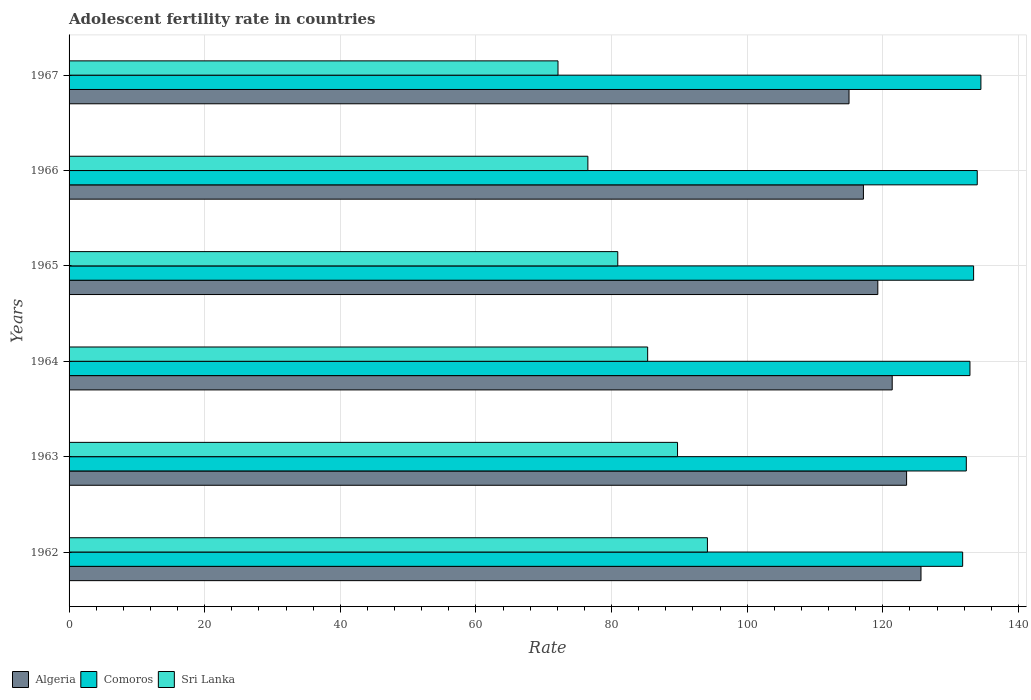Are the number of bars per tick equal to the number of legend labels?
Provide a succinct answer. Yes. What is the label of the 1st group of bars from the top?
Offer a terse response. 1967. In how many cases, is the number of bars for a given year not equal to the number of legend labels?
Offer a terse response. 0. What is the adolescent fertility rate in Comoros in 1963?
Your response must be concise. 132.31. Across all years, what is the maximum adolescent fertility rate in Algeria?
Your response must be concise. 125.62. Across all years, what is the minimum adolescent fertility rate in Sri Lanka?
Make the answer very short. 72.1. In which year was the adolescent fertility rate in Sri Lanka maximum?
Offer a terse response. 1962. In which year was the adolescent fertility rate in Sri Lanka minimum?
Your answer should be compact. 1967. What is the total adolescent fertility rate in Comoros in the graph?
Offer a very short reply. 798.68. What is the difference between the adolescent fertility rate in Algeria in 1962 and that in 1966?
Provide a short and direct response. 8.49. What is the difference between the adolescent fertility rate in Comoros in 1966 and the adolescent fertility rate in Sri Lanka in 1965?
Provide a succinct answer. 53.01. What is the average adolescent fertility rate in Algeria per year?
Your response must be concise. 120.32. In the year 1966, what is the difference between the adolescent fertility rate in Sri Lanka and adolescent fertility rate in Comoros?
Your response must be concise. -57.42. In how many years, is the adolescent fertility rate in Algeria greater than 92 ?
Provide a succinct answer. 6. What is the ratio of the adolescent fertility rate in Sri Lanka in 1966 to that in 1967?
Offer a terse response. 1.06. Is the difference between the adolescent fertility rate in Sri Lanka in 1963 and 1965 greater than the difference between the adolescent fertility rate in Comoros in 1963 and 1965?
Your answer should be very brief. Yes. What is the difference between the highest and the second highest adolescent fertility rate in Sri Lanka?
Provide a succinct answer. 4.41. What is the difference between the highest and the lowest adolescent fertility rate in Algeria?
Offer a terse response. 10.61. In how many years, is the adolescent fertility rate in Comoros greater than the average adolescent fertility rate in Comoros taken over all years?
Offer a very short reply. 3. What does the 3rd bar from the top in 1967 represents?
Offer a very short reply. Algeria. What does the 3rd bar from the bottom in 1965 represents?
Ensure brevity in your answer.  Sri Lanka. What is the difference between two consecutive major ticks on the X-axis?
Provide a short and direct response. 20. Does the graph contain any zero values?
Keep it short and to the point. No. Does the graph contain grids?
Give a very brief answer. Yes. Where does the legend appear in the graph?
Offer a terse response. Bottom left. How are the legend labels stacked?
Make the answer very short. Horizontal. What is the title of the graph?
Keep it short and to the point. Adolescent fertility rate in countries. Does "Equatorial Guinea" appear as one of the legend labels in the graph?
Provide a short and direct response. No. What is the label or title of the X-axis?
Your answer should be compact. Rate. What is the label or title of the Y-axis?
Your answer should be very brief. Years. What is the Rate in Algeria in 1962?
Provide a succinct answer. 125.62. What is the Rate in Comoros in 1962?
Your answer should be compact. 131.77. What is the Rate in Sri Lanka in 1962?
Your response must be concise. 94.13. What is the Rate in Algeria in 1963?
Ensure brevity in your answer.  123.5. What is the Rate of Comoros in 1963?
Your answer should be very brief. 132.31. What is the Rate in Sri Lanka in 1963?
Offer a very short reply. 89.72. What is the Rate in Algeria in 1964?
Provide a succinct answer. 121.38. What is the Rate in Comoros in 1964?
Make the answer very short. 132.84. What is the Rate in Sri Lanka in 1964?
Ensure brevity in your answer.  85.32. What is the Rate in Algeria in 1965?
Give a very brief answer. 119.26. What is the Rate in Comoros in 1965?
Provide a succinct answer. 133.38. What is the Rate of Sri Lanka in 1965?
Your answer should be very brief. 80.91. What is the Rate in Algeria in 1966?
Keep it short and to the point. 117.13. What is the Rate of Comoros in 1966?
Keep it short and to the point. 133.92. What is the Rate of Sri Lanka in 1966?
Offer a terse response. 76.5. What is the Rate in Algeria in 1967?
Offer a terse response. 115.01. What is the Rate in Comoros in 1967?
Make the answer very short. 134.46. What is the Rate in Sri Lanka in 1967?
Your response must be concise. 72.1. Across all years, what is the maximum Rate in Algeria?
Provide a succinct answer. 125.62. Across all years, what is the maximum Rate of Comoros?
Ensure brevity in your answer.  134.46. Across all years, what is the maximum Rate of Sri Lanka?
Provide a short and direct response. 94.13. Across all years, what is the minimum Rate of Algeria?
Keep it short and to the point. 115.01. Across all years, what is the minimum Rate of Comoros?
Your answer should be very brief. 131.77. Across all years, what is the minimum Rate of Sri Lanka?
Your answer should be very brief. 72.1. What is the total Rate in Algeria in the graph?
Offer a terse response. 721.91. What is the total Rate in Comoros in the graph?
Your answer should be compact. 798.68. What is the total Rate in Sri Lanka in the graph?
Keep it short and to the point. 498.68. What is the difference between the Rate of Algeria in 1962 and that in 1963?
Your answer should be very brief. 2.12. What is the difference between the Rate in Comoros in 1962 and that in 1963?
Your response must be concise. -0.54. What is the difference between the Rate in Sri Lanka in 1962 and that in 1963?
Offer a terse response. 4.41. What is the difference between the Rate of Algeria in 1962 and that in 1964?
Ensure brevity in your answer.  4.24. What is the difference between the Rate in Comoros in 1962 and that in 1964?
Give a very brief answer. -1.08. What is the difference between the Rate of Sri Lanka in 1962 and that in 1964?
Make the answer very short. 8.81. What is the difference between the Rate of Algeria in 1962 and that in 1965?
Your answer should be compact. 6.37. What is the difference between the Rate in Comoros in 1962 and that in 1965?
Offer a terse response. -1.61. What is the difference between the Rate of Sri Lanka in 1962 and that in 1965?
Provide a succinct answer. 13.22. What is the difference between the Rate in Algeria in 1962 and that in 1966?
Your response must be concise. 8.49. What is the difference between the Rate in Comoros in 1962 and that in 1966?
Offer a terse response. -2.15. What is the difference between the Rate in Sri Lanka in 1962 and that in 1966?
Your response must be concise. 17.63. What is the difference between the Rate in Algeria in 1962 and that in 1967?
Your response must be concise. 10.61. What is the difference between the Rate of Comoros in 1962 and that in 1967?
Provide a short and direct response. -2.69. What is the difference between the Rate of Sri Lanka in 1962 and that in 1967?
Keep it short and to the point. 22.03. What is the difference between the Rate of Algeria in 1963 and that in 1964?
Provide a short and direct response. 2.12. What is the difference between the Rate in Comoros in 1963 and that in 1964?
Offer a terse response. -0.54. What is the difference between the Rate of Sri Lanka in 1963 and that in 1964?
Your answer should be compact. 4.41. What is the difference between the Rate of Algeria in 1963 and that in 1965?
Your response must be concise. 4.24. What is the difference between the Rate in Comoros in 1963 and that in 1965?
Offer a very short reply. -1.08. What is the difference between the Rate of Sri Lanka in 1963 and that in 1965?
Your answer should be compact. 8.81. What is the difference between the Rate of Algeria in 1963 and that in 1966?
Your answer should be compact. 6.37. What is the difference between the Rate in Comoros in 1963 and that in 1966?
Your response must be concise. -1.61. What is the difference between the Rate of Sri Lanka in 1963 and that in 1966?
Provide a succinct answer. 13.22. What is the difference between the Rate of Algeria in 1963 and that in 1967?
Offer a very short reply. 8.49. What is the difference between the Rate of Comoros in 1963 and that in 1967?
Give a very brief answer. -2.15. What is the difference between the Rate in Sri Lanka in 1963 and that in 1967?
Your answer should be very brief. 17.63. What is the difference between the Rate in Algeria in 1964 and that in 1965?
Your response must be concise. 2.12. What is the difference between the Rate in Comoros in 1964 and that in 1965?
Provide a short and direct response. -0.54. What is the difference between the Rate of Sri Lanka in 1964 and that in 1965?
Give a very brief answer. 4.41. What is the difference between the Rate in Algeria in 1964 and that in 1966?
Provide a short and direct response. 4.24. What is the difference between the Rate of Comoros in 1964 and that in 1966?
Offer a terse response. -1.08. What is the difference between the Rate in Sri Lanka in 1964 and that in 1966?
Keep it short and to the point. 8.81. What is the difference between the Rate of Algeria in 1964 and that in 1967?
Your answer should be very brief. 6.37. What is the difference between the Rate in Comoros in 1964 and that in 1967?
Provide a short and direct response. -1.61. What is the difference between the Rate of Sri Lanka in 1964 and that in 1967?
Your answer should be compact. 13.22. What is the difference between the Rate in Algeria in 1965 and that in 1966?
Offer a terse response. 2.12. What is the difference between the Rate of Comoros in 1965 and that in 1966?
Provide a succinct answer. -0.54. What is the difference between the Rate in Sri Lanka in 1965 and that in 1966?
Give a very brief answer. 4.41. What is the difference between the Rate of Algeria in 1965 and that in 1967?
Your answer should be compact. 4.24. What is the difference between the Rate of Comoros in 1965 and that in 1967?
Your answer should be very brief. -1.08. What is the difference between the Rate in Sri Lanka in 1965 and that in 1967?
Provide a succinct answer. 8.81. What is the difference between the Rate in Algeria in 1966 and that in 1967?
Provide a short and direct response. 2.12. What is the difference between the Rate of Comoros in 1966 and that in 1967?
Your response must be concise. -0.54. What is the difference between the Rate in Sri Lanka in 1966 and that in 1967?
Ensure brevity in your answer.  4.41. What is the difference between the Rate of Algeria in 1962 and the Rate of Comoros in 1963?
Provide a succinct answer. -6.68. What is the difference between the Rate of Algeria in 1962 and the Rate of Sri Lanka in 1963?
Provide a short and direct response. 35.9. What is the difference between the Rate in Comoros in 1962 and the Rate in Sri Lanka in 1963?
Make the answer very short. 42.04. What is the difference between the Rate of Algeria in 1962 and the Rate of Comoros in 1964?
Your answer should be very brief. -7.22. What is the difference between the Rate in Algeria in 1962 and the Rate in Sri Lanka in 1964?
Offer a very short reply. 40.31. What is the difference between the Rate in Comoros in 1962 and the Rate in Sri Lanka in 1964?
Offer a very short reply. 46.45. What is the difference between the Rate in Algeria in 1962 and the Rate in Comoros in 1965?
Offer a very short reply. -7.76. What is the difference between the Rate of Algeria in 1962 and the Rate of Sri Lanka in 1965?
Keep it short and to the point. 44.71. What is the difference between the Rate in Comoros in 1962 and the Rate in Sri Lanka in 1965?
Provide a succinct answer. 50.86. What is the difference between the Rate in Algeria in 1962 and the Rate in Comoros in 1966?
Your answer should be compact. -8.3. What is the difference between the Rate of Algeria in 1962 and the Rate of Sri Lanka in 1966?
Your answer should be compact. 49.12. What is the difference between the Rate in Comoros in 1962 and the Rate in Sri Lanka in 1966?
Ensure brevity in your answer.  55.26. What is the difference between the Rate of Algeria in 1962 and the Rate of Comoros in 1967?
Provide a short and direct response. -8.83. What is the difference between the Rate of Algeria in 1962 and the Rate of Sri Lanka in 1967?
Your answer should be very brief. 53.53. What is the difference between the Rate of Comoros in 1962 and the Rate of Sri Lanka in 1967?
Offer a terse response. 59.67. What is the difference between the Rate of Algeria in 1963 and the Rate of Comoros in 1964?
Offer a terse response. -9.34. What is the difference between the Rate in Algeria in 1963 and the Rate in Sri Lanka in 1964?
Your response must be concise. 38.18. What is the difference between the Rate of Comoros in 1963 and the Rate of Sri Lanka in 1964?
Offer a very short reply. 46.99. What is the difference between the Rate in Algeria in 1963 and the Rate in Comoros in 1965?
Provide a succinct answer. -9.88. What is the difference between the Rate of Algeria in 1963 and the Rate of Sri Lanka in 1965?
Give a very brief answer. 42.59. What is the difference between the Rate in Comoros in 1963 and the Rate in Sri Lanka in 1965?
Keep it short and to the point. 51.4. What is the difference between the Rate of Algeria in 1963 and the Rate of Comoros in 1966?
Offer a very short reply. -10.42. What is the difference between the Rate in Algeria in 1963 and the Rate in Sri Lanka in 1966?
Your response must be concise. 47. What is the difference between the Rate in Comoros in 1963 and the Rate in Sri Lanka in 1966?
Offer a very short reply. 55.8. What is the difference between the Rate in Algeria in 1963 and the Rate in Comoros in 1967?
Ensure brevity in your answer.  -10.96. What is the difference between the Rate in Algeria in 1963 and the Rate in Sri Lanka in 1967?
Your response must be concise. 51.4. What is the difference between the Rate in Comoros in 1963 and the Rate in Sri Lanka in 1967?
Your answer should be very brief. 60.21. What is the difference between the Rate in Algeria in 1964 and the Rate in Comoros in 1965?
Provide a short and direct response. -12. What is the difference between the Rate in Algeria in 1964 and the Rate in Sri Lanka in 1965?
Your answer should be very brief. 40.47. What is the difference between the Rate of Comoros in 1964 and the Rate of Sri Lanka in 1965?
Provide a short and direct response. 51.93. What is the difference between the Rate of Algeria in 1964 and the Rate of Comoros in 1966?
Your response must be concise. -12.54. What is the difference between the Rate in Algeria in 1964 and the Rate in Sri Lanka in 1966?
Your response must be concise. 44.88. What is the difference between the Rate of Comoros in 1964 and the Rate of Sri Lanka in 1966?
Make the answer very short. 56.34. What is the difference between the Rate in Algeria in 1964 and the Rate in Comoros in 1967?
Provide a short and direct response. -13.08. What is the difference between the Rate in Algeria in 1964 and the Rate in Sri Lanka in 1967?
Your response must be concise. 49.28. What is the difference between the Rate in Comoros in 1964 and the Rate in Sri Lanka in 1967?
Offer a terse response. 60.75. What is the difference between the Rate of Algeria in 1965 and the Rate of Comoros in 1966?
Provide a succinct answer. -14.66. What is the difference between the Rate in Algeria in 1965 and the Rate in Sri Lanka in 1966?
Provide a succinct answer. 42.75. What is the difference between the Rate in Comoros in 1965 and the Rate in Sri Lanka in 1966?
Your answer should be compact. 56.88. What is the difference between the Rate of Algeria in 1965 and the Rate of Comoros in 1967?
Ensure brevity in your answer.  -15.2. What is the difference between the Rate of Algeria in 1965 and the Rate of Sri Lanka in 1967?
Keep it short and to the point. 47.16. What is the difference between the Rate of Comoros in 1965 and the Rate of Sri Lanka in 1967?
Make the answer very short. 61.28. What is the difference between the Rate of Algeria in 1966 and the Rate of Comoros in 1967?
Offer a very short reply. -17.32. What is the difference between the Rate of Algeria in 1966 and the Rate of Sri Lanka in 1967?
Ensure brevity in your answer.  45.04. What is the difference between the Rate of Comoros in 1966 and the Rate of Sri Lanka in 1967?
Your answer should be very brief. 61.82. What is the average Rate of Algeria per year?
Provide a succinct answer. 120.32. What is the average Rate of Comoros per year?
Make the answer very short. 133.11. What is the average Rate in Sri Lanka per year?
Offer a terse response. 83.11. In the year 1962, what is the difference between the Rate of Algeria and Rate of Comoros?
Offer a terse response. -6.14. In the year 1962, what is the difference between the Rate of Algeria and Rate of Sri Lanka?
Provide a short and direct response. 31.49. In the year 1962, what is the difference between the Rate of Comoros and Rate of Sri Lanka?
Provide a short and direct response. 37.64. In the year 1963, what is the difference between the Rate of Algeria and Rate of Comoros?
Your response must be concise. -8.8. In the year 1963, what is the difference between the Rate in Algeria and Rate in Sri Lanka?
Your answer should be compact. 33.78. In the year 1963, what is the difference between the Rate of Comoros and Rate of Sri Lanka?
Your response must be concise. 42.58. In the year 1964, what is the difference between the Rate of Algeria and Rate of Comoros?
Give a very brief answer. -11.46. In the year 1964, what is the difference between the Rate in Algeria and Rate in Sri Lanka?
Make the answer very short. 36.06. In the year 1964, what is the difference between the Rate of Comoros and Rate of Sri Lanka?
Provide a short and direct response. 47.53. In the year 1965, what is the difference between the Rate in Algeria and Rate in Comoros?
Provide a short and direct response. -14.13. In the year 1965, what is the difference between the Rate in Algeria and Rate in Sri Lanka?
Give a very brief answer. 38.35. In the year 1965, what is the difference between the Rate in Comoros and Rate in Sri Lanka?
Give a very brief answer. 52.47. In the year 1966, what is the difference between the Rate of Algeria and Rate of Comoros?
Ensure brevity in your answer.  -16.79. In the year 1966, what is the difference between the Rate of Algeria and Rate of Sri Lanka?
Offer a terse response. 40.63. In the year 1966, what is the difference between the Rate of Comoros and Rate of Sri Lanka?
Your answer should be compact. 57.42. In the year 1967, what is the difference between the Rate of Algeria and Rate of Comoros?
Provide a succinct answer. -19.45. In the year 1967, what is the difference between the Rate of Algeria and Rate of Sri Lanka?
Give a very brief answer. 42.91. In the year 1967, what is the difference between the Rate in Comoros and Rate in Sri Lanka?
Keep it short and to the point. 62.36. What is the ratio of the Rate of Algeria in 1962 to that in 1963?
Provide a short and direct response. 1.02. What is the ratio of the Rate in Comoros in 1962 to that in 1963?
Make the answer very short. 1. What is the ratio of the Rate of Sri Lanka in 1962 to that in 1963?
Your answer should be very brief. 1.05. What is the ratio of the Rate of Algeria in 1962 to that in 1964?
Offer a terse response. 1.03. What is the ratio of the Rate of Sri Lanka in 1962 to that in 1964?
Offer a very short reply. 1.1. What is the ratio of the Rate in Algeria in 1962 to that in 1965?
Keep it short and to the point. 1.05. What is the ratio of the Rate of Comoros in 1962 to that in 1965?
Give a very brief answer. 0.99. What is the ratio of the Rate of Sri Lanka in 1962 to that in 1965?
Provide a short and direct response. 1.16. What is the ratio of the Rate of Algeria in 1962 to that in 1966?
Your answer should be very brief. 1.07. What is the ratio of the Rate of Comoros in 1962 to that in 1966?
Keep it short and to the point. 0.98. What is the ratio of the Rate in Sri Lanka in 1962 to that in 1966?
Give a very brief answer. 1.23. What is the ratio of the Rate of Algeria in 1962 to that in 1967?
Make the answer very short. 1.09. What is the ratio of the Rate in Sri Lanka in 1962 to that in 1967?
Provide a short and direct response. 1.31. What is the ratio of the Rate in Algeria in 1963 to that in 1964?
Keep it short and to the point. 1.02. What is the ratio of the Rate in Sri Lanka in 1963 to that in 1964?
Give a very brief answer. 1.05. What is the ratio of the Rate of Algeria in 1963 to that in 1965?
Make the answer very short. 1.04. What is the ratio of the Rate of Comoros in 1963 to that in 1965?
Ensure brevity in your answer.  0.99. What is the ratio of the Rate of Sri Lanka in 1963 to that in 1965?
Offer a very short reply. 1.11. What is the ratio of the Rate of Algeria in 1963 to that in 1966?
Provide a succinct answer. 1.05. What is the ratio of the Rate of Comoros in 1963 to that in 1966?
Your response must be concise. 0.99. What is the ratio of the Rate of Sri Lanka in 1963 to that in 1966?
Make the answer very short. 1.17. What is the ratio of the Rate of Algeria in 1963 to that in 1967?
Offer a terse response. 1.07. What is the ratio of the Rate in Sri Lanka in 1963 to that in 1967?
Make the answer very short. 1.24. What is the ratio of the Rate of Algeria in 1964 to that in 1965?
Provide a short and direct response. 1.02. What is the ratio of the Rate in Sri Lanka in 1964 to that in 1965?
Give a very brief answer. 1.05. What is the ratio of the Rate in Algeria in 1964 to that in 1966?
Make the answer very short. 1.04. What is the ratio of the Rate of Comoros in 1964 to that in 1966?
Ensure brevity in your answer.  0.99. What is the ratio of the Rate in Sri Lanka in 1964 to that in 1966?
Give a very brief answer. 1.12. What is the ratio of the Rate in Algeria in 1964 to that in 1967?
Make the answer very short. 1.06. What is the ratio of the Rate of Sri Lanka in 1964 to that in 1967?
Make the answer very short. 1.18. What is the ratio of the Rate of Algeria in 1965 to that in 1966?
Provide a succinct answer. 1.02. What is the ratio of the Rate of Sri Lanka in 1965 to that in 1966?
Your answer should be compact. 1.06. What is the ratio of the Rate of Algeria in 1965 to that in 1967?
Give a very brief answer. 1.04. What is the ratio of the Rate in Sri Lanka in 1965 to that in 1967?
Offer a terse response. 1.12. What is the ratio of the Rate in Algeria in 1966 to that in 1967?
Ensure brevity in your answer.  1.02. What is the ratio of the Rate of Comoros in 1966 to that in 1967?
Offer a terse response. 1. What is the ratio of the Rate in Sri Lanka in 1966 to that in 1967?
Provide a short and direct response. 1.06. What is the difference between the highest and the second highest Rate of Algeria?
Your answer should be compact. 2.12. What is the difference between the highest and the second highest Rate of Comoros?
Your response must be concise. 0.54. What is the difference between the highest and the second highest Rate of Sri Lanka?
Provide a short and direct response. 4.41. What is the difference between the highest and the lowest Rate of Algeria?
Provide a short and direct response. 10.61. What is the difference between the highest and the lowest Rate in Comoros?
Your response must be concise. 2.69. What is the difference between the highest and the lowest Rate in Sri Lanka?
Provide a succinct answer. 22.03. 